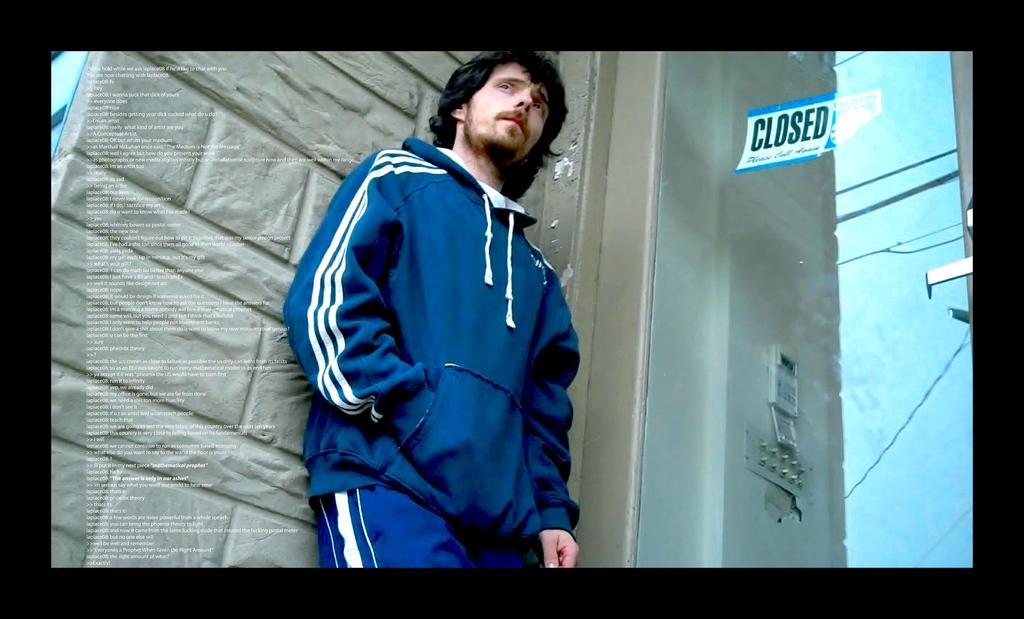Provide a one-sentence caption for the provided image. Man standing in front of a building that says "Closed". 